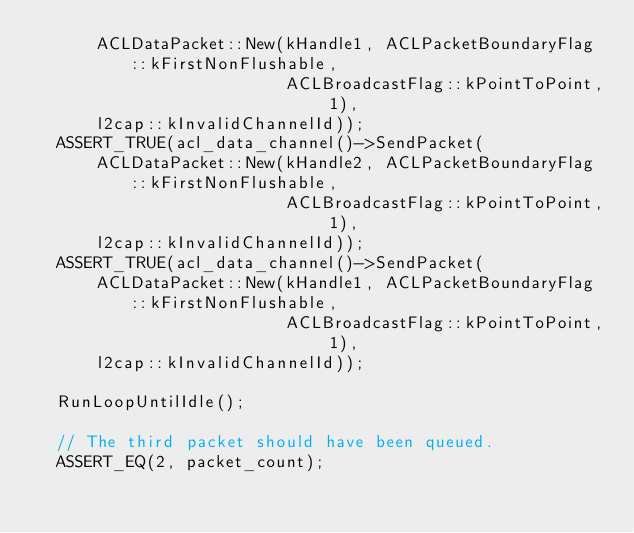Convert code to text. <code><loc_0><loc_0><loc_500><loc_500><_C++_>      ACLDataPacket::New(kHandle1, ACLPacketBoundaryFlag::kFirstNonFlushable,
                         ACLBroadcastFlag::kPointToPoint, 1),
      l2cap::kInvalidChannelId));
  ASSERT_TRUE(acl_data_channel()->SendPacket(
      ACLDataPacket::New(kHandle2, ACLPacketBoundaryFlag::kFirstNonFlushable,
                         ACLBroadcastFlag::kPointToPoint, 1),
      l2cap::kInvalidChannelId));
  ASSERT_TRUE(acl_data_channel()->SendPacket(
      ACLDataPacket::New(kHandle1, ACLPacketBoundaryFlag::kFirstNonFlushable,
                         ACLBroadcastFlag::kPointToPoint, 1),
      l2cap::kInvalidChannelId));

  RunLoopUntilIdle();

  // The third packet should have been queued.
  ASSERT_EQ(2, packet_count);
</code> 